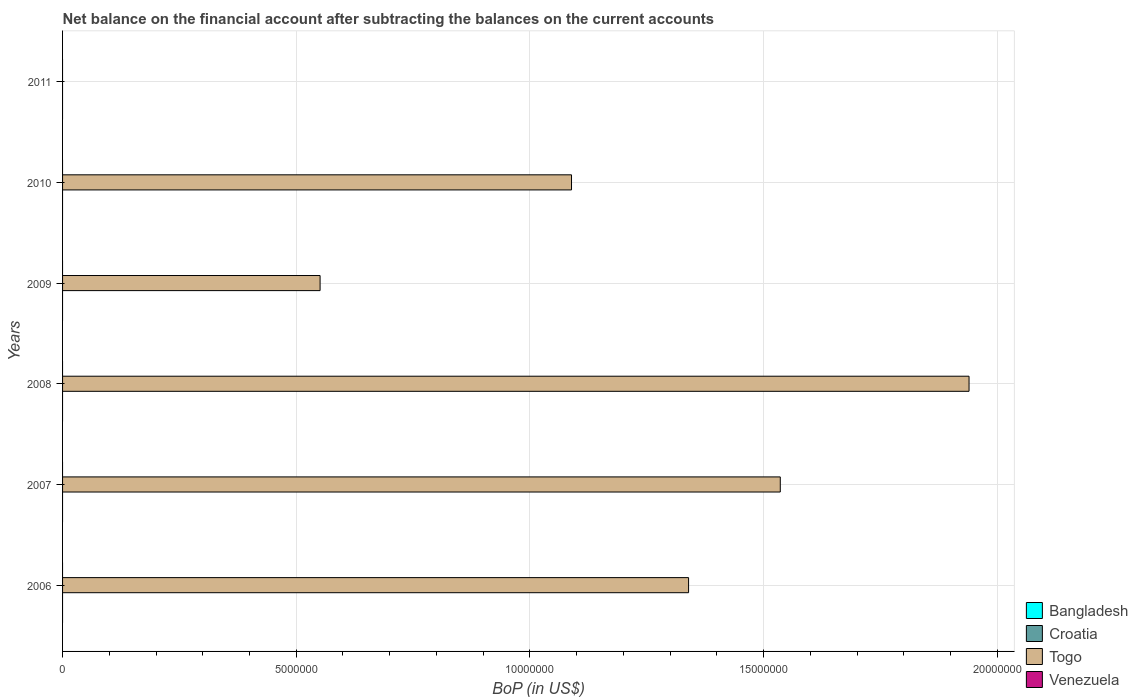How many different coloured bars are there?
Provide a succinct answer. 1. Are the number of bars on each tick of the Y-axis equal?
Give a very brief answer. No. How many bars are there on the 3rd tick from the top?
Your answer should be very brief. 1. What is the Balance of Payments in Togo in 2011?
Keep it short and to the point. 0. In which year was the Balance of Payments in Togo maximum?
Offer a terse response. 2008. What is the total Balance of Payments in Bangladesh in the graph?
Your response must be concise. 0. What is the difference between the Balance of Payments in Croatia in 2010 and the Balance of Payments in Bangladesh in 2009?
Your answer should be compact. 0. What is the ratio of the Balance of Payments in Togo in 2009 to that in 2010?
Offer a terse response. 0.51. Is the Balance of Payments in Togo in 2006 less than that in 2010?
Keep it short and to the point. No. What is the difference between the highest and the second highest Balance of Payments in Togo?
Ensure brevity in your answer.  4.04e+06. What is the difference between the highest and the lowest Balance of Payments in Togo?
Provide a succinct answer. 1.94e+07. In how many years, is the Balance of Payments in Bangladesh greater than the average Balance of Payments in Bangladesh taken over all years?
Give a very brief answer. 0. Is it the case that in every year, the sum of the Balance of Payments in Croatia and Balance of Payments in Togo is greater than the sum of Balance of Payments in Venezuela and Balance of Payments in Bangladesh?
Ensure brevity in your answer.  No. What is the difference between two consecutive major ticks on the X-axis?
Offer a terse response. 5.00e+06. Does the graph contain any zero values?
Your answer should be compact. Yes. How many legend labels are there?
Make the answer very short. 4. What is the title of the graph?
Your response must be concise. Net balance on the financial account after subtracting the balances on the current accounts. What is the label or title of the X-axis?
Keep it short and to the point. BoP (in US$). What is the label or title of the Y-axis?
Offer a terse response. Years. What is the BoP (in US$) of Croatia in 2006?
Offer a terse response. 0. What is the BoP (in US$) of Togo in 2006?
Your answer should be compact. 1.34e+07. What is the BoP (in US$) in Venezuela in 2006?
Your answer should be very brief. 0. What is the BoP (in US$) in Togo in 2007?
Offer a terse response. 1.54e+07. What is the BoP (in US$) of Bangladesh in 2008?
Ensure brevity in your answer.  0. What is the BoP (in US$) in Togo in 2008?
Provide a short and direct response. 1.94e+07. What is the BoP (in US$) of Venezuela in 2008?
Give a very brief answer. 0. What is the BoP (in US$) of Togo in 2009?
Provide a short and direct response. 5.51e+06. What is the BoP (in US$) in Venezuela in 2009?
Give a very brief answer. 0. What is the BoP (in US$) of Croatia in 2010?
Offer a very short reply. 0. What is the BoP (in US$) of Togo in 2010?
Your answer should be compact. 1.09e+07. What is the BoP (in US$) of Venezuela in 2010?
Keep it short and to the point. 0. What is the BoP (in US$) of Bangladesh in 2011?
Offer a terse response. 0. What is the BoP (in US$) in Croatia in 2011?
Give a very brief answer. 0. What is the BoP (in US$) in Venezuela in 2011?
Ensure brevity in your answer.  0. Across all years, what is the maximum BoP (in US$) in Togo?
Offer a very short reply. 1.94e+07. Across all years, what is the minimum BoP (in US$) of Togo?
Provide a succinct answer. 0. What is the total BoP (in US$) of Bangladesh in the graph?
Give a very brief answer. 0. What is the total BoP (in US$) of Togo in the graph?
Your answer should be very brief. 6.45e+07. What is the total BoP (in US$) in Venezuela in the graph?
Make the answer very short. 0. What is the difference between the BoP (in US$) in Togo in 2006 and that in 2007?
Your response must be concise. -1.96e+06. What is the difference between the BoP (in US$) of Togo in 2006 and that in 2008?
Provide a short and direct response. -6.00e+06. What is the difference between the BoP (in US$) of Togo in 2006 and that in 2009?
Provide a succinct answer. 7.88e+06. What is the difference between the BoP (in US$) in Togo in 2006 and that in 2010?
Offer a terse response. 2.50e+06. What is the difference between the BoP (in US$) of Togo in 2007 and that in 2008?
Your response must be concise. -4.04e+06. What is the difference between the BoP (in US$) in Togo in 2007 and that in 2009?
Your answer should be very brief. 9.85e+06. What is the difference between the BoP (in US$) of Togo in 2007 and that in 2010?
Provide a short and direct response. 4.47e+06. What is the difference between the BoP (in US$) of Togo in 2008 and that in 2009?
Your response must be concise. 1.39e+07. What is the difference between the BoP (in US$) in Togo in 2008 and that in 2010?
Your answer should be compact. 8.51e+06. What is the difference between the BoP (in US$) of Togo in 2009 and that in 2010?
Your answer should be very brief. -5.38e+06. What is the average BoP (in US$) in Bangladesh per year?
Provide a short and direct response. 0. What is the average BoP (in US$) of Togo per year?
Make the answer very short. 1.08e+07. What is the average BoP (in US$) of Venezuela per year?
Your answer should be very brief. 0. What is the ratio of the BoP (in US$) of Togo in 2006 to that in 2007?
Give a very brief answer. 0.87. What is the ratio of the BoP (in US$) in Togo in 2006 to that in 2008?
Give a very brief answer. 0.69. What is the ratio of the BoP (in US$) of Togo in 2006 to that in 2009?
Ensure brevity in your answer.  2.43. What is the ratio of the BoP (in US$) in Togo in 2006 to that in 2010?
Your answer should be very brief. 1.23. What is the ratio of the BoP (in US$) in Togo in 2007 to that in 2008?
Make the answer very short. 0.79. What is the ratio of the BoP (in US$) of Togo in 2007 to that in 2009?
Your response must be concise. 2.79. What is the ratio of the BoP (in US$) in Togo in 2007 to that in 2010?
Give a very brief answer. 1.41. What is the ratio of the BoP (in US$) in Togo in 2008 to that in 2009?
Your answer should be very brief. 3.52. What is the ratio of the BoP (in US$) of Togo in 2008 to that in 2010?
Give a very brief answer. 1.78. What is the ratio of the BoP (in US$) in Togo in 2009 to that in 2010?
Your response must be concise. 0.51. What is the difference between the highest and the second highest BoP (in US$) of Togo?
Keep it short and to the point. 4.04e+06. What is the difference between the highest and the lowest BoP (in US$) in Togo?
Ensure brevity in your answer.  1.94e+07. 